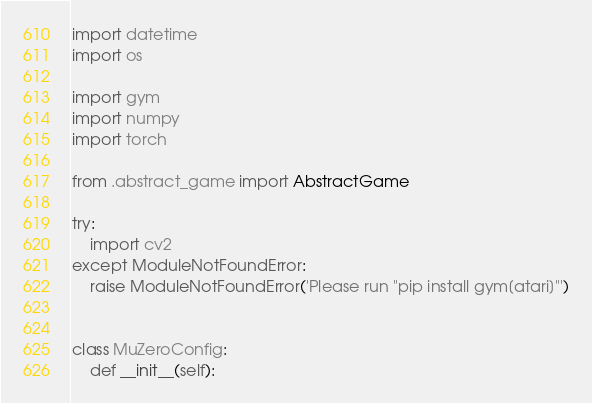Convert code to text. <code><loc_0><loc_0><loc_500><loc_500><_Python_>import datetime
import os

import gym
import numpy
import torch

from .abstract_game import AbstractGame

try:
    import cv2
except ModuleNotFoundError:
    raise ModuleNotFoundError('Please run "pip install gym[atari]"')


class MuZeroConfig:
    def __init__(self):</code> 